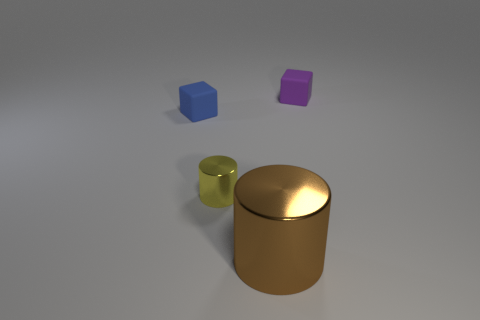Add 3 tiny blue matte blocks. How many objects exist? 7 Subtract all red shiny cubes. Subtract all tiny purple objects. How many objects are left? 3 Add 1 purple matte cubes. How many purple matte cubes are left? 2 Add 3 purple objects. How many purple objects exist? 4 Subtract 0 red cylinders. How many objects are left? 4 